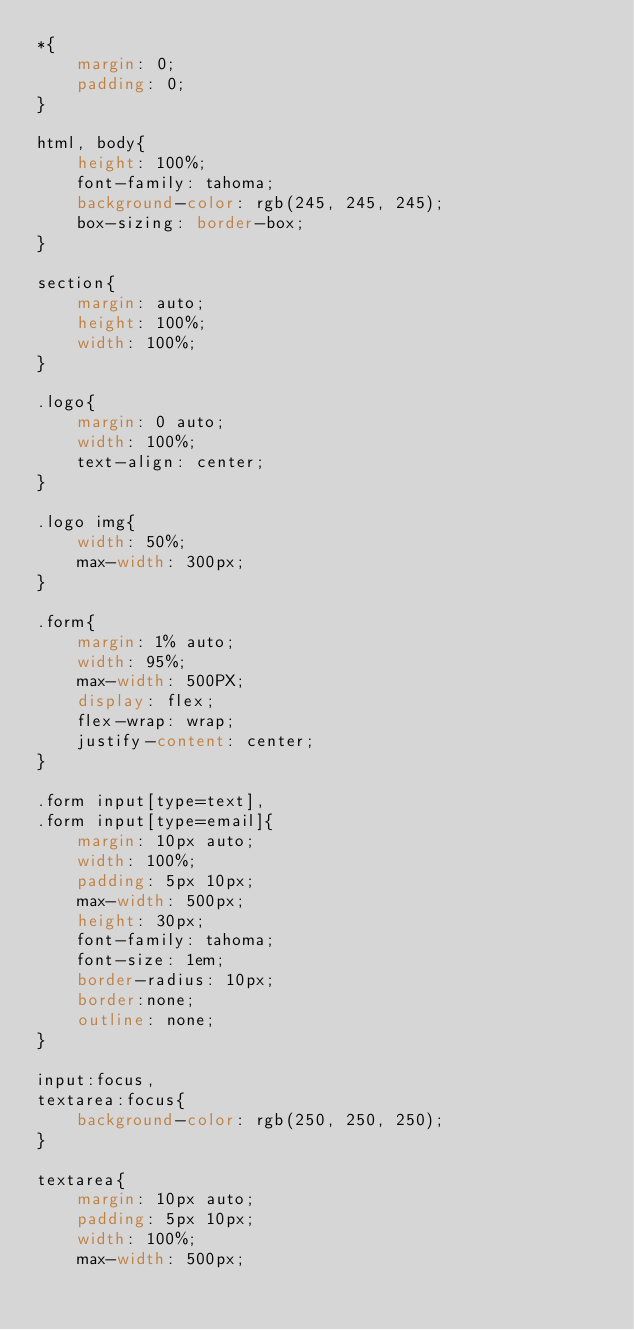Convert code to text. <code><loc_0><loc_0><loc_500><loc_500><_CSS_>*{
    margin: 0;
    padding: 0;
}

html, body{
    height: 100%;
    font-family: tahoma;
    background-color: rgb(245, 245, 245);
    box-sizing: border-box;
}

section{
    margin: auto;
    height: 100%;
    width: 100%;
}

.logo{
    margin: 0 auto;
    width: 100%;
    text-align: center;
}

.logo img{
    width: 50%;
    max-width: 300px;
}

.form{
    margin: 1% auto;
    width: 95%;
    max-width: 500PX;
    display: flex;
    flex-wrap: wrap;
    justify-content: center;
}

.form input[type=text],
.form input[type=email]{
    margin: 10px auto;
    width: 100%;
    padding: 5px 10px;
    max-width: 500px;
    height: 30px;
    font-family: tahoma;
    font-size: 1em;
    border-radius: 10px;
    border:none;
    outline: none;
}

input:focus,
textarea:focus{
    background-color: rgb(250, 250, 250);
}

textarea{
    margin: 10px auto;
    padding: 5px 10px;
    width: 100%;
    max-width: 500px;</code> 